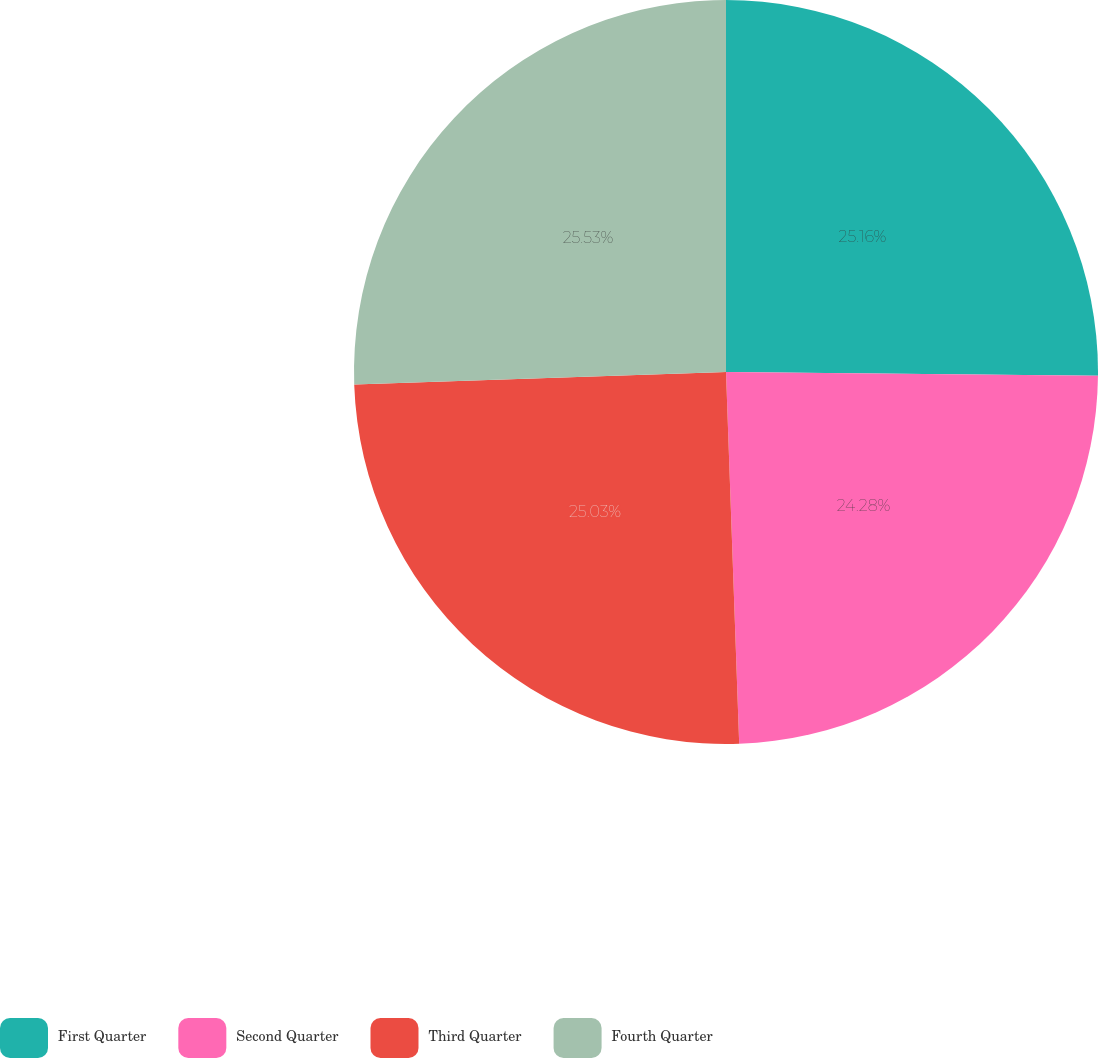<chart> <loc_0><loc_0><loc_500><loc_500><pie_chart><fcel>First Quarter<fcel>Second Quarter<fcel>Third Quarter<fcel>Fourth Quarter<nl><fcel>25.16%<fcel>24.28%<fcel>25.03%<fcel>25.54%<nl></chart> 